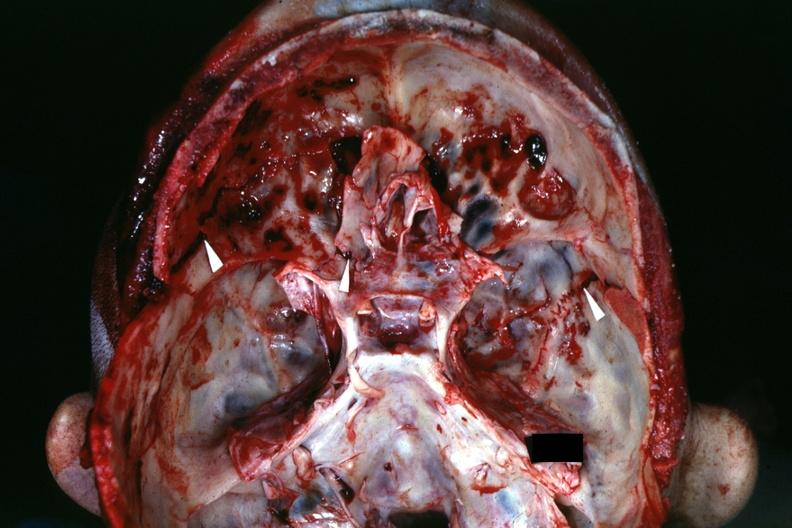what is present?
Answer the question using a single word or phrase. Bone, calvarium 